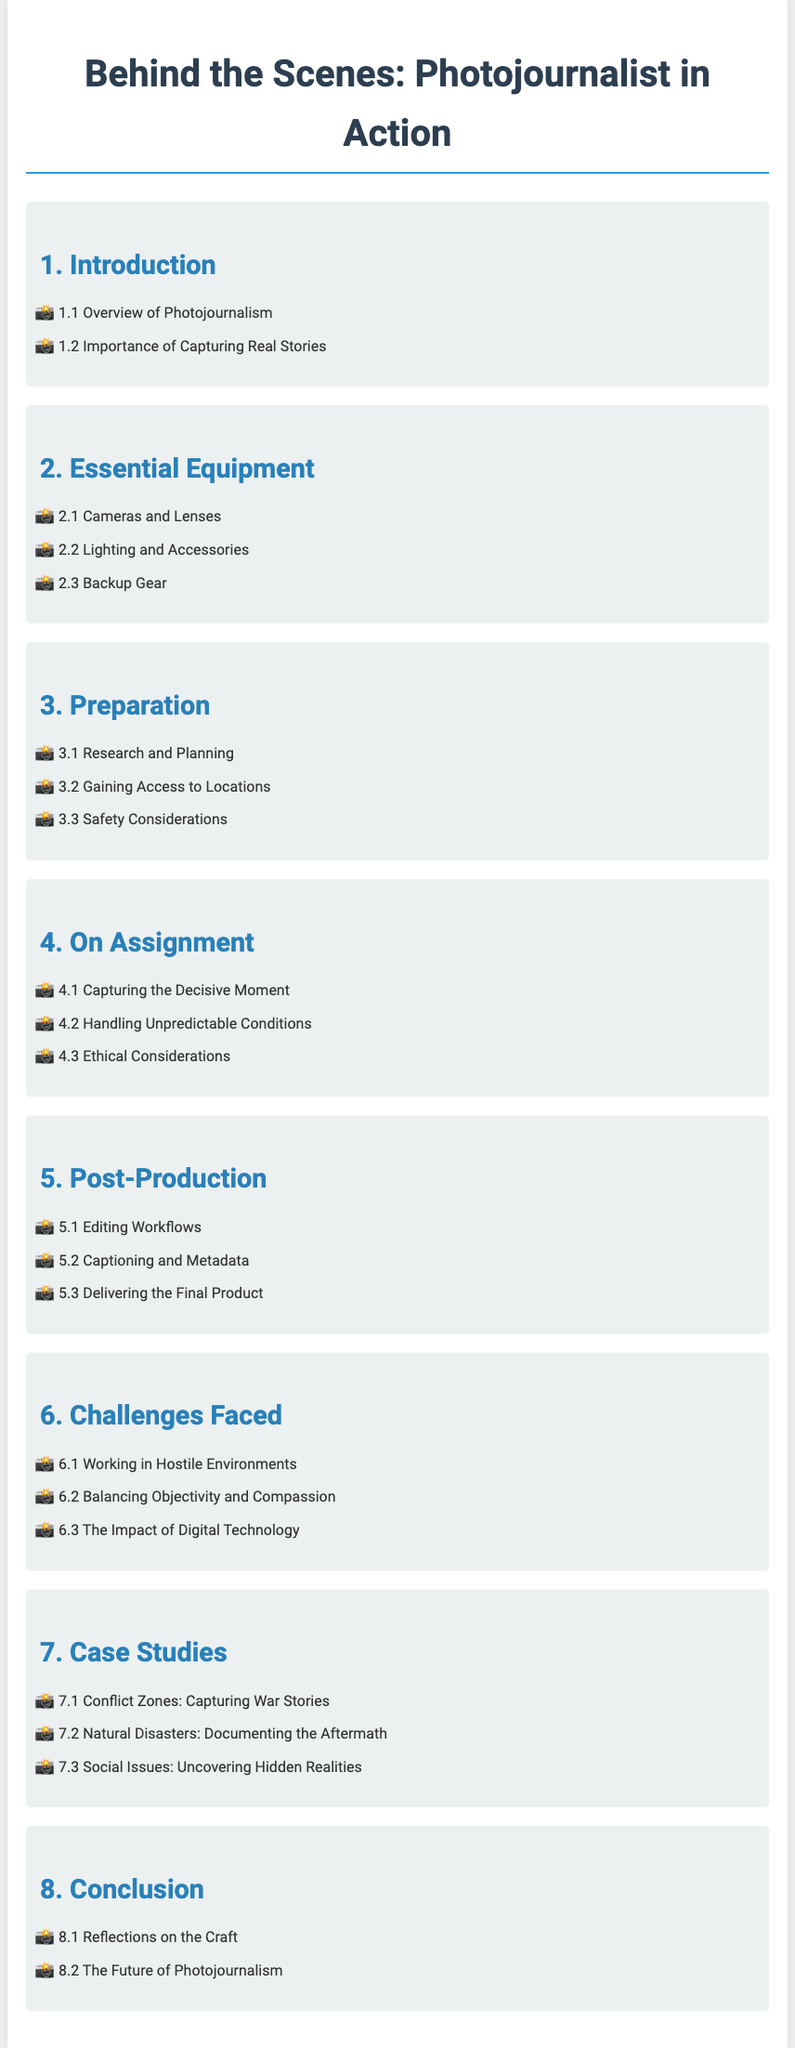What is the title of the document? The title of the document is specified at the top of the rendered page.
Answer: Behind the Scenes: Photojournalist in Action How many sections are there in this document? The total number of main sections in the document is listed in the index.
Answer: Eight What is covered in section 3? Section 3 is about the necessary steps taken before assignments are executed.
Answer: Preparation Which aspect is discussed in section 6.1? Section 6.1 highlights the challenges faced by photojournalists in specific environments.
Answer: Working in Hostile Environments What is the focus of section 4.2? Section 4.2 elaborates on the conditions that may affect the assignment outcomes.
Answer: Handling Unpredictable Conditions What does section 5 primarily focus on? Section 5 details the processes involved after capturing images.
Answer: Post-Production How many case studies are presented in section 7? The number of case studies is indicated in section 7's bullet points.
Answer: Three What ethical aspect is covered in section 4.3? Section 4.3 addresses moral concerns that photojournalists may encounter.
Answer: Ethical Considerations 